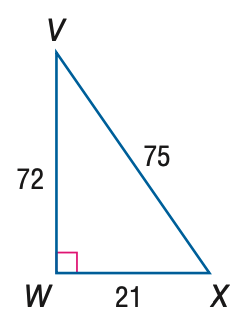Answer the mathemtical geometry problem and directly provide the correct option letter.
Question: Express the ratio of \tan X as a decimal to the nearest hundredth.
Choices: A: 0.28 B: 0.29 C: 0.96 D: 3.43 D 